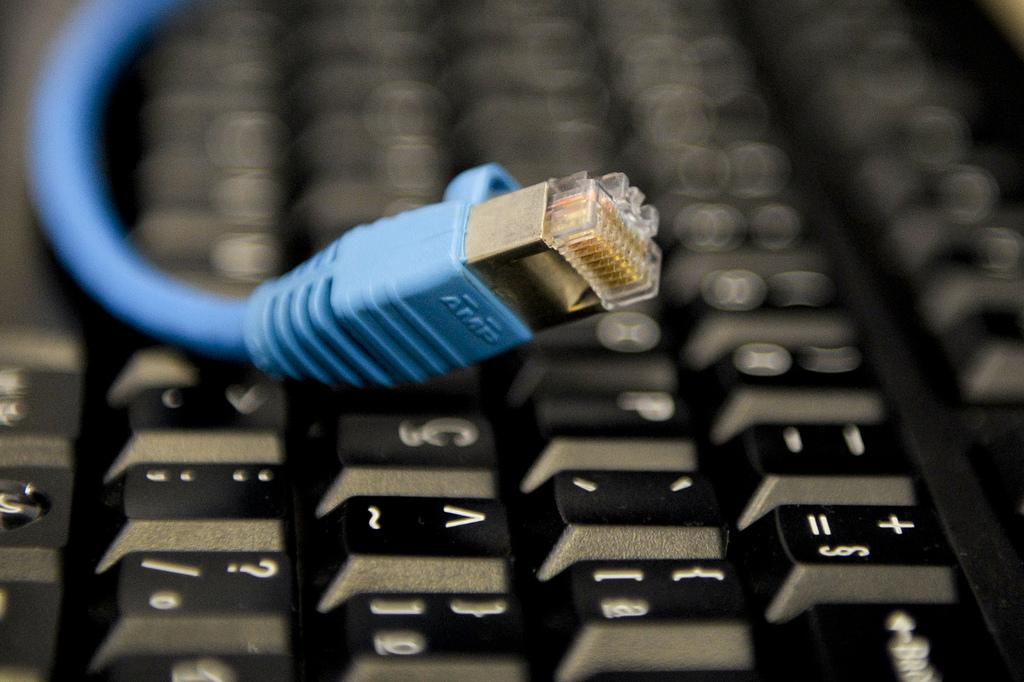<image>
Relay a brief, clear account of the picture shown. the blue AMP cable is on top of the keyboard 